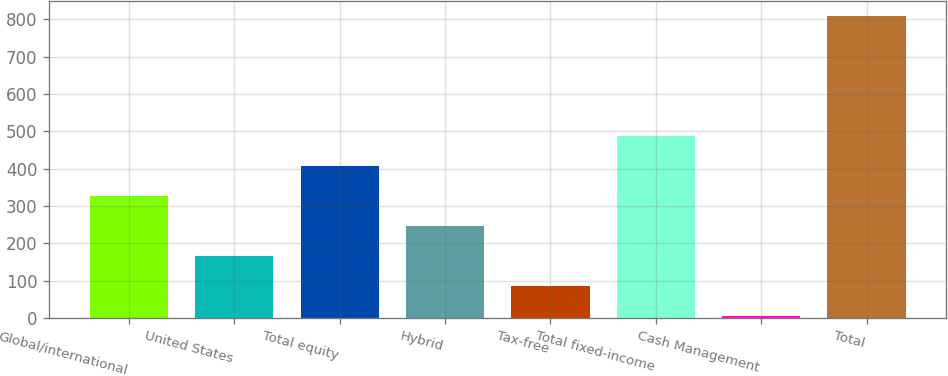<chart> <loc_0><loc_0><loc_500><loc_500><bar_chart><fcel>Global/international<fcel>United States<fcel>Total equity<fcel>Hybrid<fcel>Tax-free<fcel>Total fixed-income<fcel>Cash Management<fcel>Total<nl><fcel>326.88<fcel>166.44<fcel>407.1<fcel>246.66<fcel>86.22<fcel>487.32<fcel>6<fcel>808.2<nl></chart> 